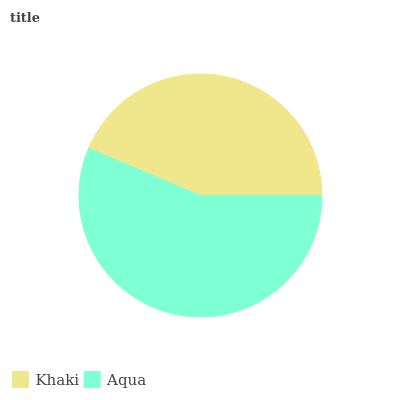Is Khaki the minimum?
Answer yes or no. Yes. Is Aqua the maximum?
Answer yes or no. Yes. Is Aqua the minimum?
Answer yes or no. No. Is Aqua greater than Khaki?
Answer yes or no. Yes. Is Khaki less than Aqua?
Answer yes or no. Yes. Is Khaki greater than Aqua?
Answer yes or no. No. Is Aqua less than Khaki?
Answer yes or no. No. Is Aqua the high median?
Answer yes or no. Yes. Is Khaki the low median?
Answer yes or no. Yes. Is Khaki the high median?
Answer yes or no. No. Is Aqua the low median?
Answer yes or no. No. 